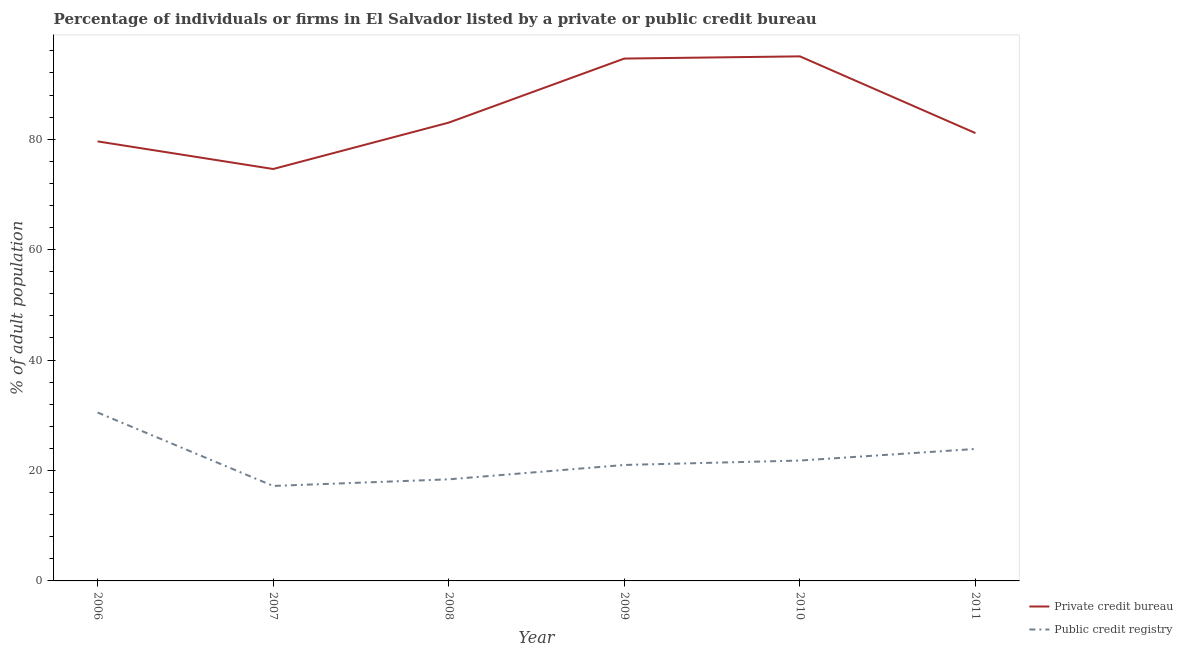What is the percentage of firms listed by private credit bureau in 2006?
Provide a short and direct response. 79.6. Across all years, what is the maximum percentage of firms listed by public credit bureau?
Give a very brief answer. 30.5. Across all years, what is the minimum percentage of firms listed by public credit bureau?
Provide a succinct answer. 17.2. In which year was the percentage of firms listed by private credit bureau maximum?
Give a very brief answer. 2010. In which year was the percentage of firms listed by public credit bureau minimum?
Your answer should be very brief. 2007. What is the total percentage of firms listed by public credit bureau in the graph?
Your answer should be compact. 132.8. What is the difference between the percentage of firms listed by private credit bureau in 2008 and that in 2011?
Your answer should be very brief. 1.9. What is the difference between the percentage of firms listed by public credit bureau in 2011 and the percentage of firms listed by private credit bureau in 2007?
Offer a very short reply. -50.7. What is the average percentage of firms listed by private credit bureau per year?
Give a very brief answer. 84.65. In the year 2006, what is the difference between the percentage of firms listed by public credit bureau and percentage of firms listed by private credit bureau?
Keep it short and to the point. -49.1. In how many years, is the percentage of firms listed by private credit bureau greater than 36 %?
Your answer should be compact. 6. What is the ratio of the percentage of firms listed by private credit bureau in 2009 to that in 2011?
Give a very brief answer. 1.17. Is the percentage of firms listed by public credit bureau in 2007 less than that in 2009?
Your response must be concise. Yes. Is the difference between the percentage of firms listed by private credit bureau in 2008 and 2011 greater than the difference between the percentage of firms listed by public credit bureau in 2008 and 2011?
Your answer should be compact. Yes. What is the difference between the highest and the second highest percentage of firms listed by private credit bureau?
Your answer should be compact. 0.4. Does the percentage of firms listed by public credit bureau monotonically increase over the years?
Provide a succinct answer. No. How many years are there in the graph?
Provide a succinct answer. 6. What is the difference between two consecutive major ticks on the Y-axis?
Provide a succinct answer. 20. Are the values on the major ticks of Y-axis written in scientific E-notation?
Keep it short and to the point. No. Does the graph contain any zero values?
Your answer should be very brief. No. Where does the legend appear in the graph?
Your answer should be compact. Bottom right. What is the title of the graph?
Give a very brief answer. Percentage of individuals or firms in El Salvador listed by a private or public credit bureau. Does "Non-solid fuel" appear as one of the legend labels in the graph?
Provide a short and direct response. No. What is the label or title of the X-axis?
Give a very brief answer. Year. What is the label or title of the Y-axis?
Your answer should be compact. % of adult population. What is the % of adult population in Private credit bureau in 2006?
Keep it short and to the point. 79.6. What is the % of adult population of Public credit registry in 2006?
Your answer should be very brief. 30.5. What is the % of adult population in Private credit bureau in 2007?
Your response must be concise. 74.6. What is the % of adult population of Private credit bureau in 2008?
Make the answer very short. 83. What is the % of adult population of Private credit bureau in 2009?
Ensure brevity in your answer.  94.6. What is the % of adult population in Private credit bureau in 2010?
Give a very brief answer. 95. What is the % of adult population of Public credit registry in 2010?
Your response must be concise. 21.8. What is the % of adult population in Private credit bureau in 2011?
Offer a very short reply. 81.1. What is the % of adult population of Public credit registry in 2011?
Your response must be concise. 23.9. Across all years, what is the maximum % of adult population of Private credit bureau?
Your response must be concise. 95. Across all years, what is the maximum % of adult population in Public credit registry?
Offer a terse response. 30.5. Across all years, what is the minimum % of adult population of Private credit bureau?
Offer a terse response. 74.6. What is the total % of adult population in Private credit bureau in the graph?
Give a very brief answer. 507.9. What is the total % of adult population of Public credit registry in the graph?
Give a very brief answer. 132.8. What is the difference between the % of adult population in Public credit registry in 2006 and that in 2007?
Offer a very short reply. 13.3. What is the difference between the % of adult population of Private credit bureau in 2006 and that in 2008?
Provide a short and direct response. -3.4. What is the difference between the % of adult population in Public credit registry in 2006 and that in 2009?
Your answer should be very brief. 9.5. What is the difference between the % of adult population of Private credit bureau in 2006 and that in 2010?
Offer a terse response. -15.4. What is the difference between the % of adult population in Private credit bureau in 2007 and that in 2009?
Offer a terse response. -20. What is the difference between the % of adult population in Private credit bureau in 2007 and that in 2010?
Offer a terse response. -20.4. What is the difference between the % of adult population in Private credit bureau in 2007 and that in 2011?
Your answer should be very brief. -6.5. What is the difference between the % of adult population in Public credit registry in 2007 and that in 2011?
Provide a succinct answer. -6.7. What is the difference between the % of adult population of Private credit bureau in 2008 and that in 2010?
Your response must be concise. -12. What is the difference between the % of adult population in Public credit registry in 2008 and that in 2010?
Provide a short and direct response. -3.4. What is the difference between the % of adult population of Private credit bureau in 2008 and that in 2011?
Provide a short and direct response. 1.9. What is the difference between the % of adult population of Public credit registry in 2008 and that in 2011?
Ensure brevity in your answer.  -5.5. What is the difference between the % of adult population of Private credit bureau in 2009 and that in 2010?
Your response must be concise. -0.4. What is the difference between the % of adult population in Public credit registry in 2009 and that in 2011?
Offer a very short reply. -2.9. What is the difference between the % of adult population of Private credit bureau in 2010 and that in 2011?
Offer a very short reply. 13.9. What is the difference between the % of adult population of Private credit bureau in 2006 and the % of adult population of Public credit registry in 2007?
Your answer should be very brief. 62.4. What is the difference between the % of adult population in Private credit bureau in 2006 and the % of adult population in Public credit registry in 2008?
Give a very brief answer. 61.2. What is the difference between the % of adult population in Private credit bureau in 2006 and the % of adult population in Public credit registry in 2009?
Give a very brief answer. 58.6. What is the difference between the % of adult population of Private credit bureau in 2006 and the % of adult population of Public credit registry in 2010?
Make the answer very short. 57.8. What is the difference between the % of adult population of Private credit bureau in 2006 and the % of adult population of Public credit registry in 2011?
Your answer should be compact. 55.7. What is the difference between the % of adult population in Private credit bureau in 2007 and the % of adult population in Public credit registry in 2008?
Provide a succinct answer. 56.2. What is the difference between the % of adult population in Private credit bureau in 2007 and the % of adult population in Public credit registry in 2009?
Provide a short and direct response. 53.6. What is the difference between the % of adult population in Private credit bureau in 2007 and the % of adult population in Public credit registry in 2010?
Offer a very short reply. 52.8. What is the difference between the % of adult population in Private credit bureau in 2007 and the % of adult population in Public credit registry in 2011?
Provide a succinct answer. 50.7. What is the difference between the % of adult population in Private credit bureau in 2008 and the % of adult population in Public credit registry in 2010?
Ensure brevity in your answer.  61.2. What is the difference between the % of adult population in Private credit bureau in 2008 and the % of adult population in Public credit registry in 2011?
Give a very brief answer. 59.1. What is the difference between the % of adult population of Private credit bureau in 2009 and the % of adult population of Public credit registry in 2010?
Provide a succinct answer. 72.8. What is the difference between the % of adult population of Private credit bureau in 2009 and the % of adult population of Public credit registry in 2011?
Make the answer very short. 70.7. What is the difference between the % of adult population in Private credit bureau in 2010 and the % of adult population in Public credit registry in 2011?
Offer a terse response. 71.1. What is the average % of adult population in Private credit bureau per year?
Make the answer very short. 84.65. What is the average % of adult population of Public credit registry per year?
Make the answer very short. 22.13. In the year 2006, what is the difference between the % of adult population in Private credit bureau and % of adult population in Public credit registry?
Offer a very short reply. 49.1. In the year 2007, what is the difference between the % of adult population in Private credit bureau and % of adult population in Public credit registry?
Offer a terse response. 57.4. In the year 2008, what is the difference between the % of adult population of Private credit bureau and % of adult population of Public credit registry?
Keep it short and to the point. 64.6. In the year 2009, what is the difference between the % of adult population of Private credit bureau and % of adult population of Public credit registry?
Ensure brevity in your answer.  73.6. In the year 2010, what is the difference between the % of adult population of Private credit bureau and % of adult population of Public credit registry?
Offer a very short reply. 73.2. In the year 2011, what is the difference between the % of adult population in Private credit bureau and % of adult population in Public credit registry?
Ensure brevity in your answer.  57.2. What is the ratio of the % of adult population in Private credit bureau in 2006 to that in 2007?
Provide a short and direct response. 1.07. What is the ratio of the % of adult population of Public credit registry in 2006 to that in 2007?
Give a very brief answer. 1.77. What is the ratio of the % of adult population of Public credit registry in 2006 to that in 2008?
Provide a short and direct response. 1.66. What is the ratio of the % of adult population in Private credit bureau in 2006 to that in 2009?
Offer a terse response. 0.84. What is the ratio of the % of adult population in Public credit registry in 2006 to that in 2009?
Make the answer very short. 1.45. What is the ratio of the % of adult population in Private credit bureau in 2006 to that in 2010?
Offer a very short reply. 0.84. What is the ratio of the % of adult population in Public credit registry in 2006 to that in 2010?
Your response must be concise. 1.4. What is the ratio of the % of adult population in Private credit bureau in 2006 to that in 2011?
Your response must be concise. 0.98. What is the ratio of the % of adult population in Public credit registry in 2006 to that in 2011?
Provide a short and direct response. 1.28. What is the ratio of the % of adult population in Private credit bureau in 2007 to that in 2008?
Provide a succinct answer. 0.9. What is the ratio of the % of adult population of Public credit registry in 2007 to that in 2008?
Make the answer very short. 0.93. What is the ratio of the % of adult population in Private credit bureau in 2007 to that in 2009?
Give a very brief answer. 0.79. What is the ratio of the % of adult population in Public credit registry in 2007 to that in 2009?
Offer a very short reply. 0.82. What is the ratio of the % of adult population of Private credit bureau in 2007 to that in 2010?
Provide a succinct answer. 0.79. What is the ratio of the % of adult population of Public credit registry in 2007 to that in 2010?
Provide a short and direct response. 0.79. What is the ratio of the % of adult population in Private credit bureau in 2007 to that in 2011?
Provide a succinct answer. 0.92. What is the ratio of the % of adult population in Public credit registry in 2007 to that in 2011?
Keep it short and to the point. 0.72. What is the ratio of the % of adult population in Private credit bureau in 2008 to that in 2009?
Provide a succinct answer. 0.88. What is the ratio of the % of adult population of Public credit registry in 2008 to that in 2009?
Give a very brief answer. 0.88. What is the ratio of the % of adult population of Private credit bureau in 2008 to that in 2010?
Offer a very short reply. 0.87. What is the ratio of the % of adult population in Public credit registry in 2008 to that in 2010?
Provide a short and direct response. 0.84. What is the ratio of the % of adult population of Private credit bureau in 2008 to that in 2011?
Provide a short and direct response. 1.02. What is the ratio of the % of adult population in Public credit registry in 2008 to that in 2011?
Keep it short and to the point. 0.77. What is the ratio of the % of adult population of Public credit registry in 2009 to that in 2010?
Your answer should be very brief. 0.96. What is the ratio of the % of adult population of Private credit bureau in 2009 to that in 2011?
Keep it short and to the point. 1.17. What is the ratio of the % of adult population in Public credit registry in 2009 to that in 2011?
Your answer should be very brief. 0.88. What is the ratio of the % of adult population in Private credit bureau in 2010 to that in 2011?
Ensure brevity in your answer.  1.17. What is the ratio of the % of adult population of Public credit registry in 2010 to that in 2011?
Provide a succinct answer. 0.91. What is the difference between the highest and the lowest % of adult population of Private credit bureau?
Give a very brief answer. 20.4. 